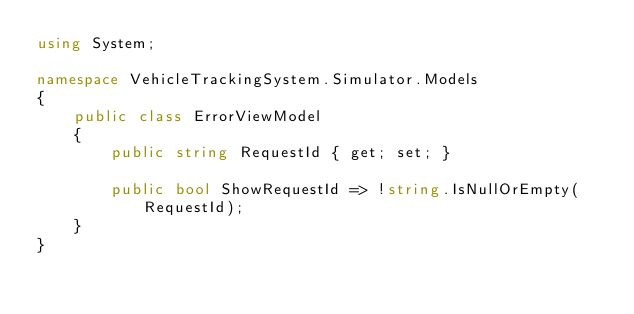<code> <loc_0><loc_0><loc_500><loc_500><_C#_>using System;

namespace VehicleTrackingSystem.Simulator.Models
{
    public class ErrorViewModel
    {
        public string RequestId { get; set; }

        public bool ShowRequestId => !string.IsNullOrEmpty(RequestId);
    }
}</code> 